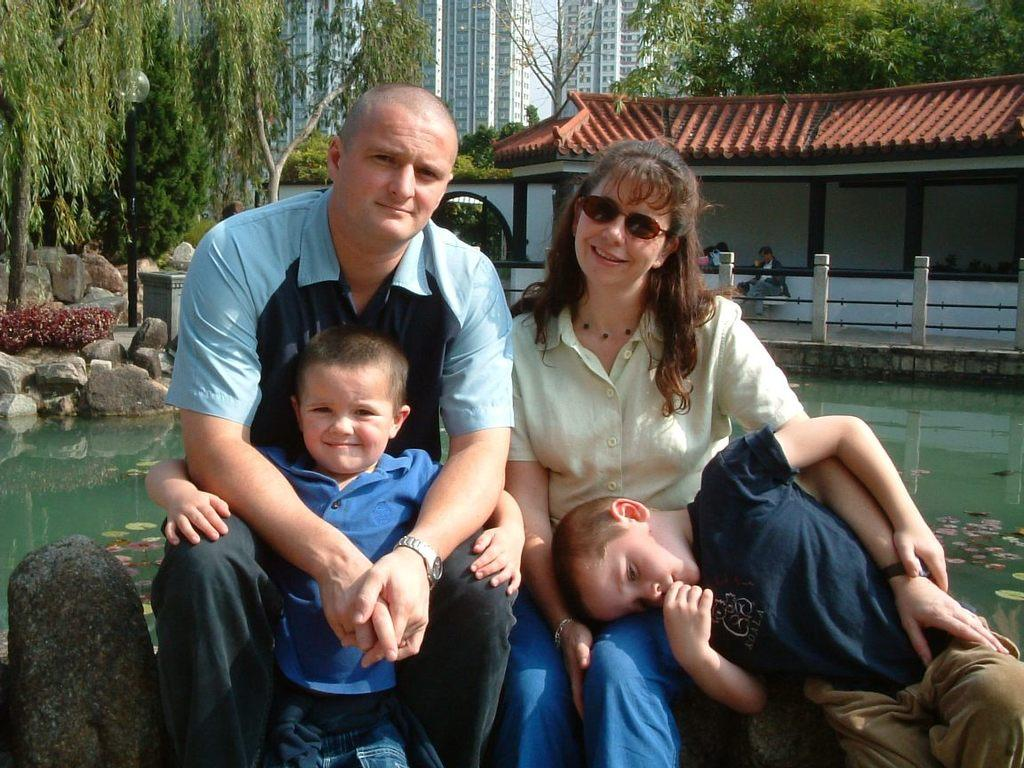Who is in the image? There is a family in the image. Where are they sitting? The family is sitting on a rock. What can be seen behind the rock? There is a pond behind the rock. What is visible in the background? There is a building and trees present in the background. What else can be seen in the background? Stones are present in the background. What degree does the crook have in the image? There is no crook present in the image, so it is not possible to determine if they have a degree. 